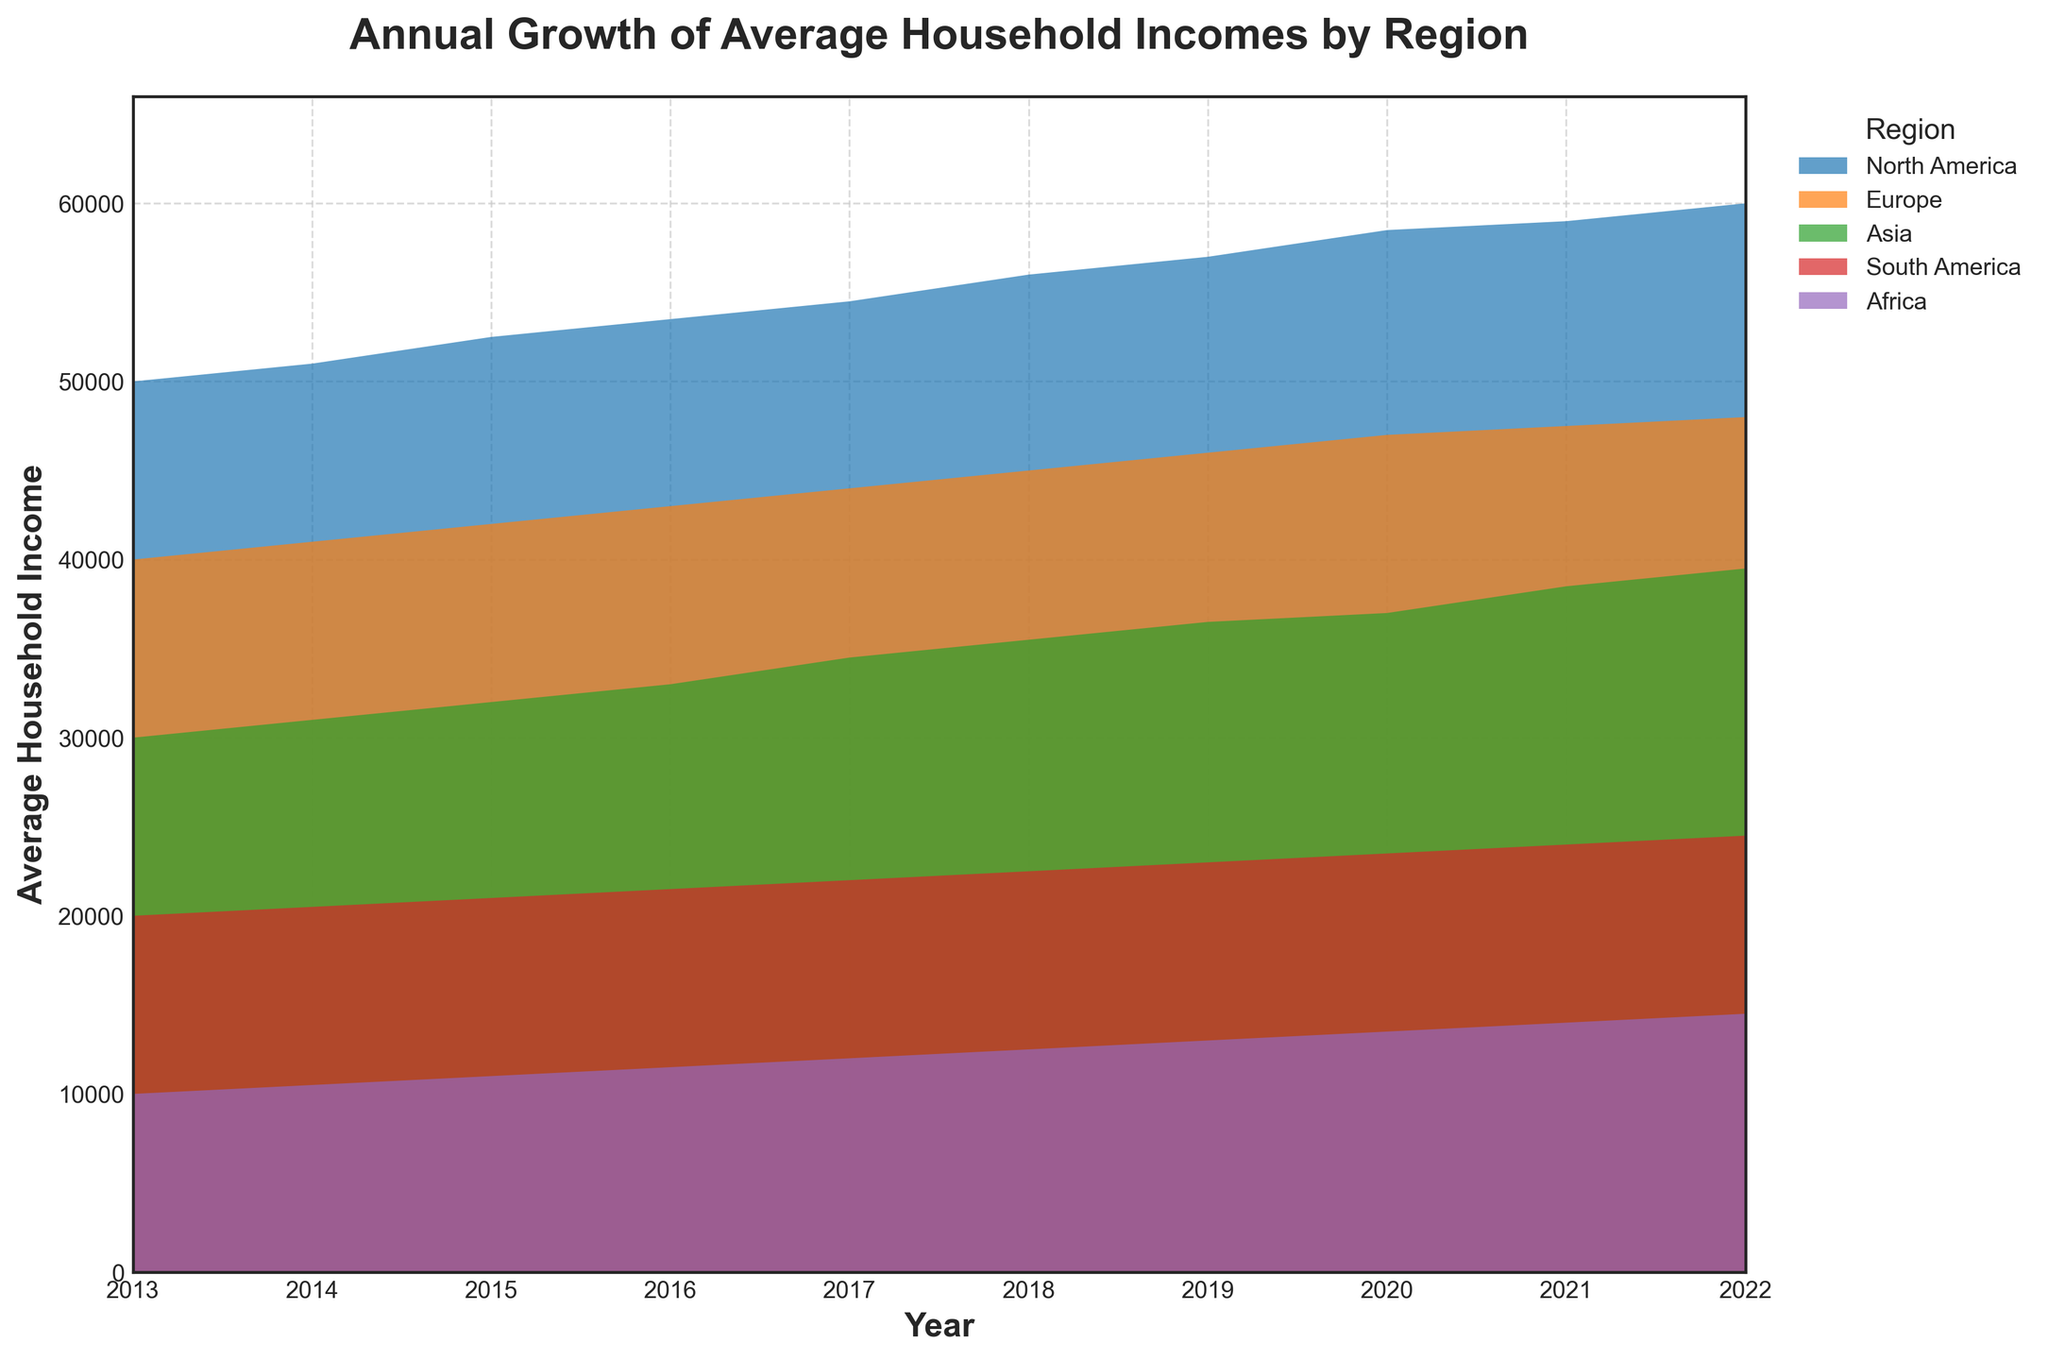What is the title of the figure? The title of the figure is usually displayed at the top of the chart and summarizes the overall topic of the figure. In this case, the title is "Annual Growth of Average Household Incomes by Region" as indicated in the code provided.
Answer: Annual Growth of Average Household Incomes by Region Which region had the highest average household income in 2022? To determine this, we need to look at the values for the year 2022 for each region. The figure shows that North America has the highest average household income in 2022.
Answer: North America How much did the average household income in North America increase from 2013 to 2022? Calculate the difference between the values for North America in 2022 and 2013. The income in 2022 is 60,000 and in 2013 is 50,000. The increase is 60,000 - 50,000.
Answer: 10,000 Which regions experienced a steady increase in household income throughout the decade? A steady increase would show a continuous upward trend without any dips. By observing the area chart, North America, Europe, Asia, South America, and Africa all show a steady increase in household income over the years.
Answer: North America, Europe, Asia, South America, Africa Compare the growth rate of average household income in Africa and Europe between 2013 and 2022. Which one had a higher growth rate? To find the growth rate, we calculate the difference between 2022 and 2013 for both Africa and Europe, and then compare. Africa: 14,500 - 10,000 = 4,500. Europe: 48,000 - 40,000 = 8,000. Europe had a higher growth rate.
Answer: Europe During which year did Asia's average household income surpass 35,000? Find the first year where Asia's household income value exceeds 35,000 in the figure. According to the data, it happened in 2017.
Answer: 2017 What is the difference between the average household incomes of North America and South America in 2022? Subtract the 2022 value for South America from the 2022 value for North America: 60,000 - 24,500 = 35,500.
Answer: 35,500 How does South America's growth in average household income compare to Africa's over the decade? Calculate the increase in household income for both South America and Africa from 2013 to 2022. South America: 24,500 - 20,000 = 4,500. Africa: 14,500 - 10,000 = 4,500. Both regions have the same growth in terms of increase.
Answer: Same Which region had the smallest increase in household income from 2013 to 2022? Calculate the difference for each region and identify the smallest value. Africa's increase is 4,500, Europe's increase is 8,000, Asia's increase is 9,500, South America's increase is 4,500, and North America's increase is 10,000. Africa and South America both had the smallest increase, tied at 4,500.
Answer: Africa and South America What is the average household income in Europe in the midpoint of the decade (2017)? The value for Europe in the year 2017 can be directly obtained from the figure. It is 44,000.
Answer: 44,000 